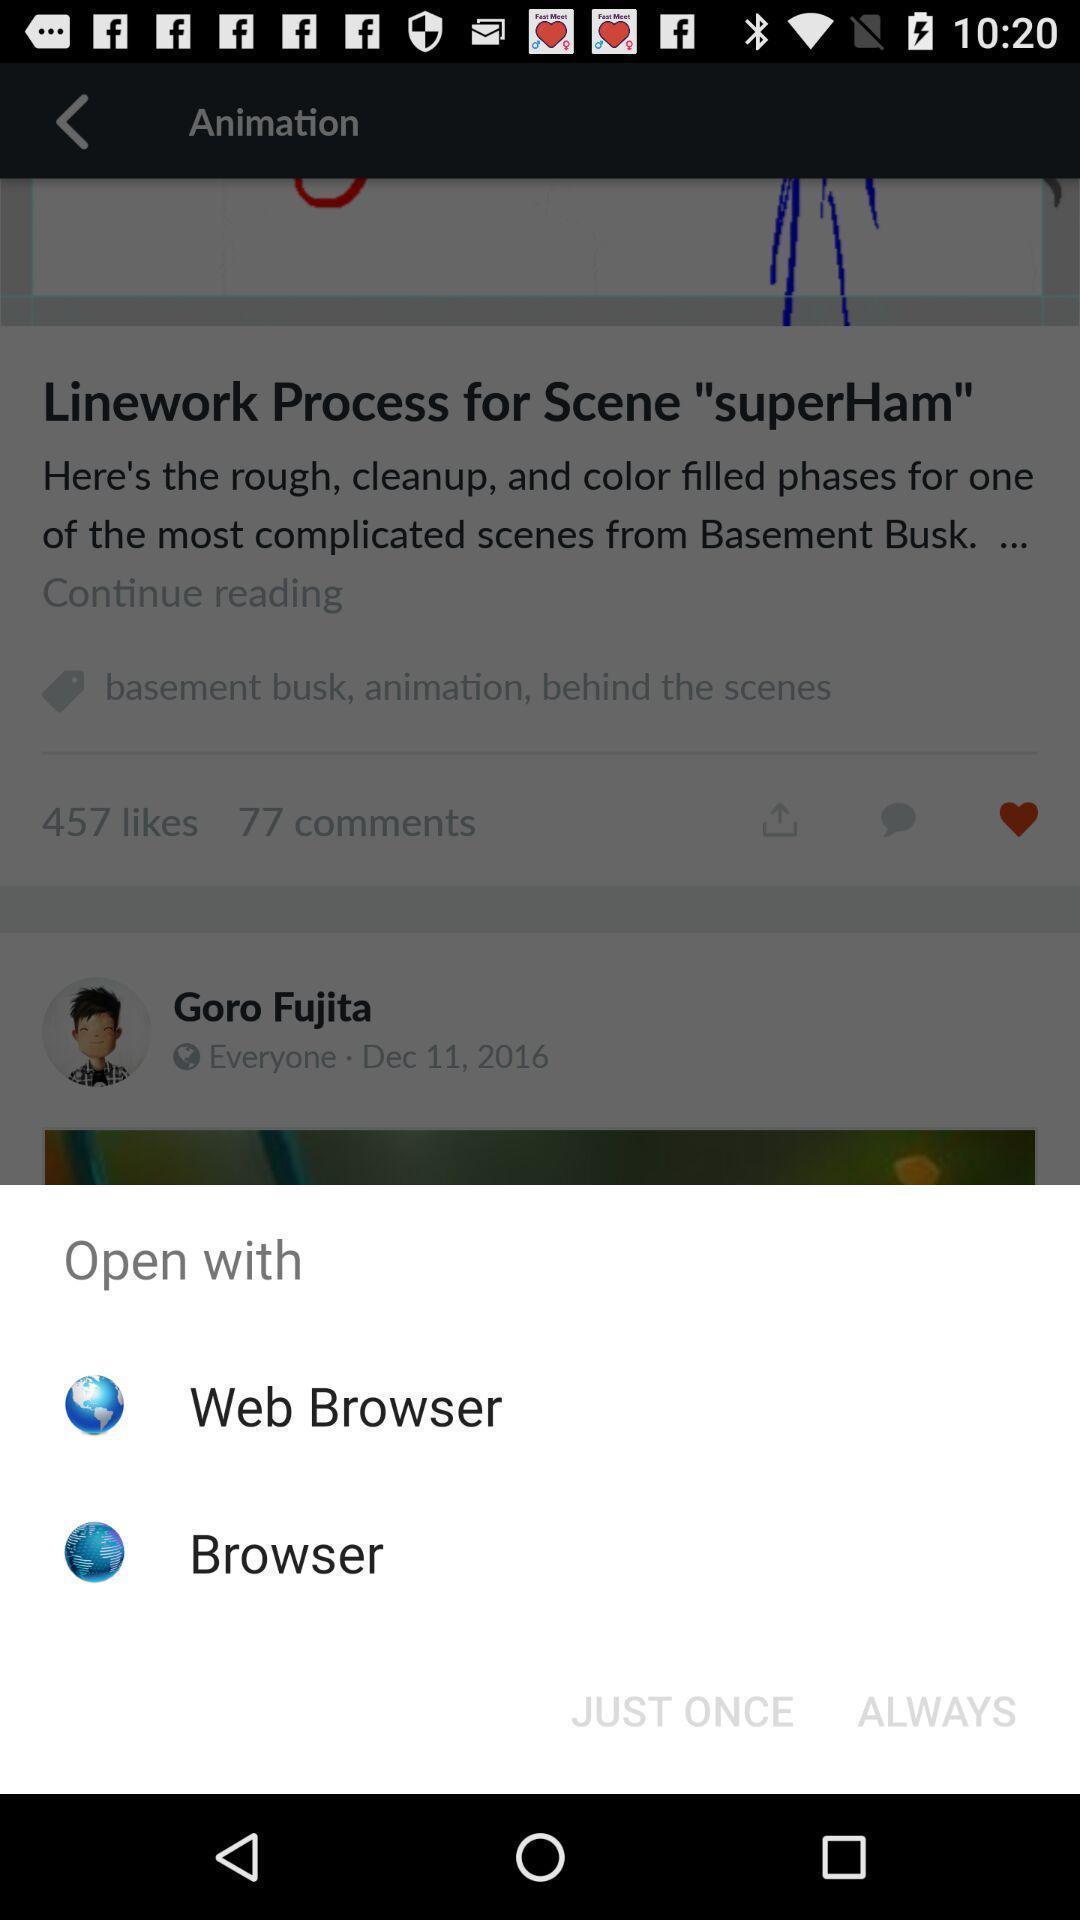Summarize the information in this screenshot. Pop-up showing multiple options to open. 